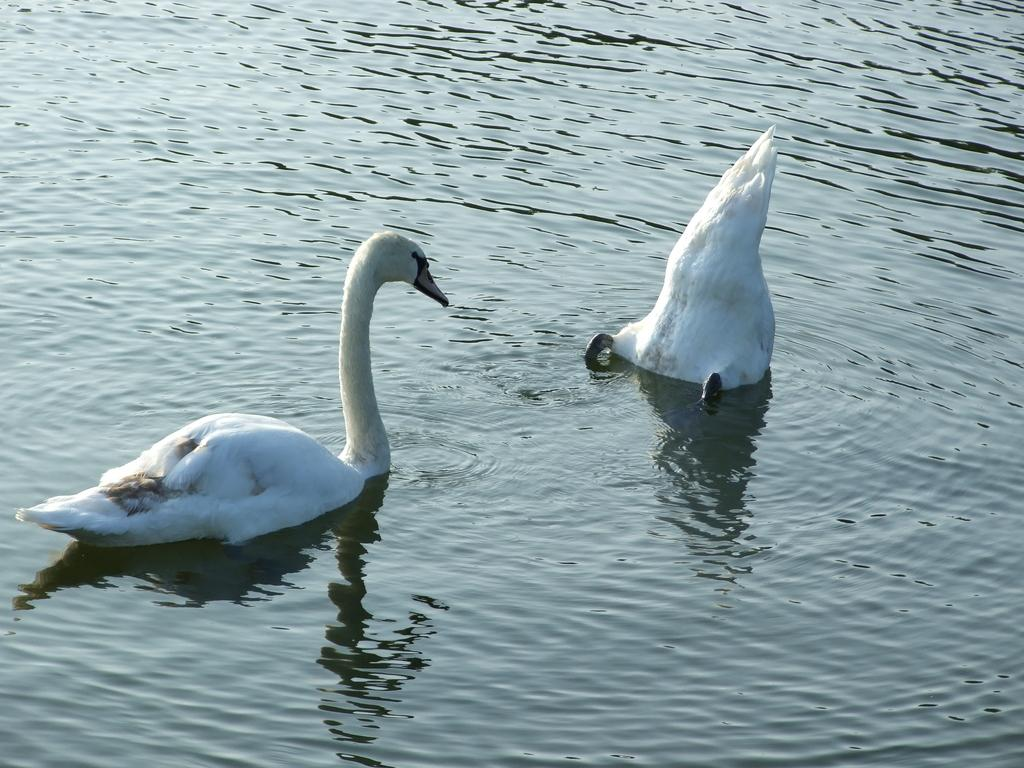How many birds are in the image? There are two birds in the image. Where are the birds located in the image? The birds are in the water. What is the name of the sun in the image? There is no sun present in the image, so it is not possible to determine its name. 